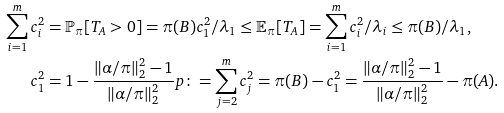<formula> <loc_0><loc_0><loc_500><loc_500>\sum _ { i = 1 } ^ { m } c _ { i } ^ { 2 } & = \mathbb { P } _ { \pi } [ T _ { A } > 0 ] = \pi ( B ) c _ { 1 } ^ { 2 } / \lambda _ { 1 } \leq \mathbb { E } _ { \pi } [ T _ { A } ] = \sum _ { i = 1 } ^ { m } c _ { i } ^ { 2 } / \lambda _ { i } \leq \pi ( B ) / \lambda _ { 1 } , \\ c _ { 1 } ^ { 2 } & = 1 - \frac { \| \alpha / \pi \| _ { 2 } ^ { 2 } - 1 } { \| \alpha / \pi \| _ { 2 } ^ { 2 } } p \colon = \sum _ { j = 2 } ^ { m } c _ { j } ^ { 2 } = \pi ( B ) - c _ { 1 } ^ { 2 } = \frac { \| \alpha / \pi \| _ { 2 } ^ { 2 } - 1 } { \| \alpha / \pi \| _ { 2 } ^ { 2 } } - \pi ( A ) .</formula> 